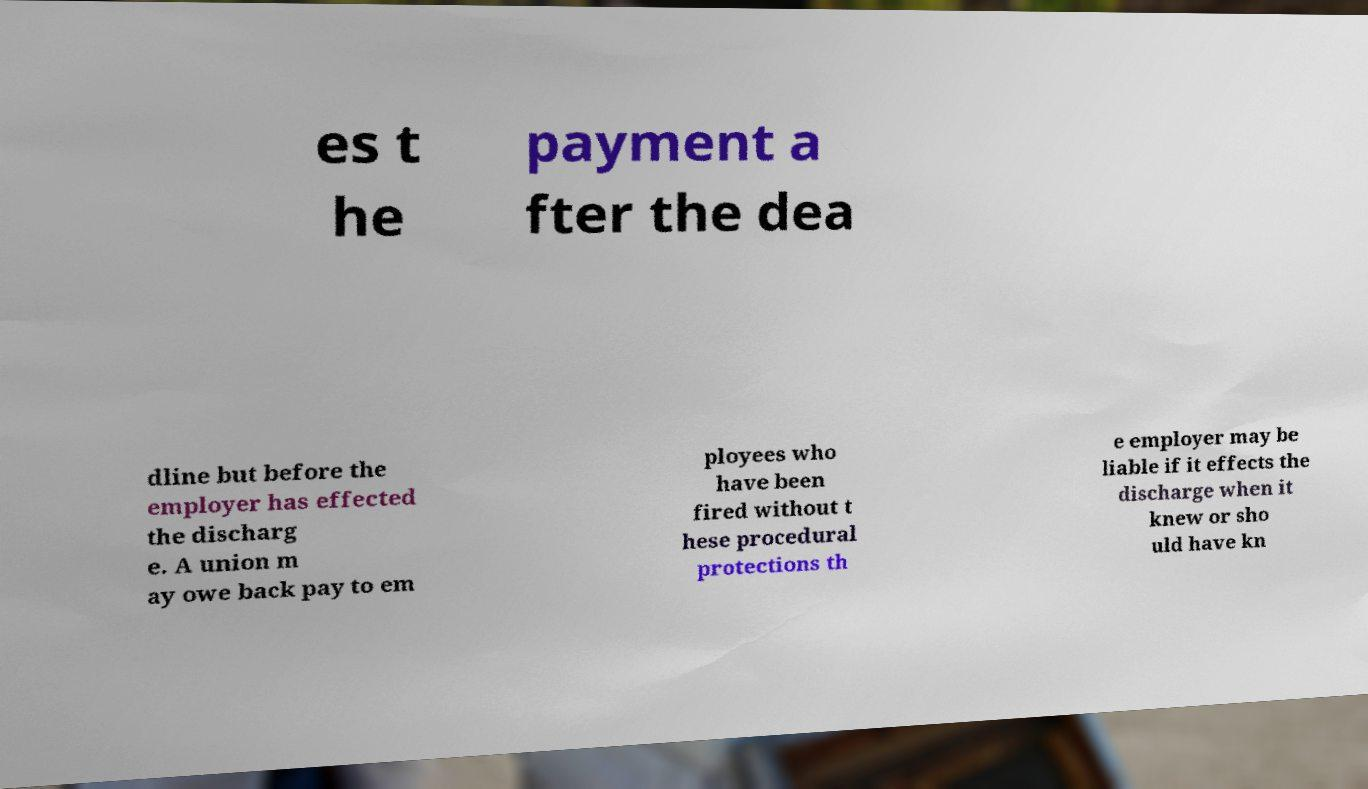I need the written content from this picture converted into text. Can you do that? es t he payment a fter the dea dline but before the employer has effected the discharg e. A union m ay owe back pay to em ployees who have been fired without t hese procedural protections th e employer may be liable if it effects the discharge when it knew or sho uld have kn 